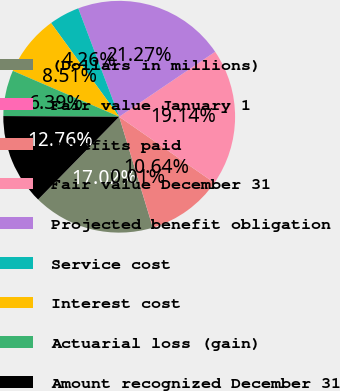Convert chart. <chart><loc_0><loc_0><loc_500><loc_500><pie_chart><fcel>(Dollars in millions)<fcel>Fair value January 1<fcel>Benefits paid<fcel>Fair value December 31<fcel>Projected benefit obligation<fcel>Service cost<fcel>Interest cost<fcel>Actuarial loss (gain)<fcel>Amount recognized December 31<nl><fcel>17.02%<fcel>0.01%<fcel>10.64%<fcel>19.14%<fcel>21.27%<fcel>4.26%<fcel>8.51%<fcel>6.39%<fcel>12.76%<nl></chart> 